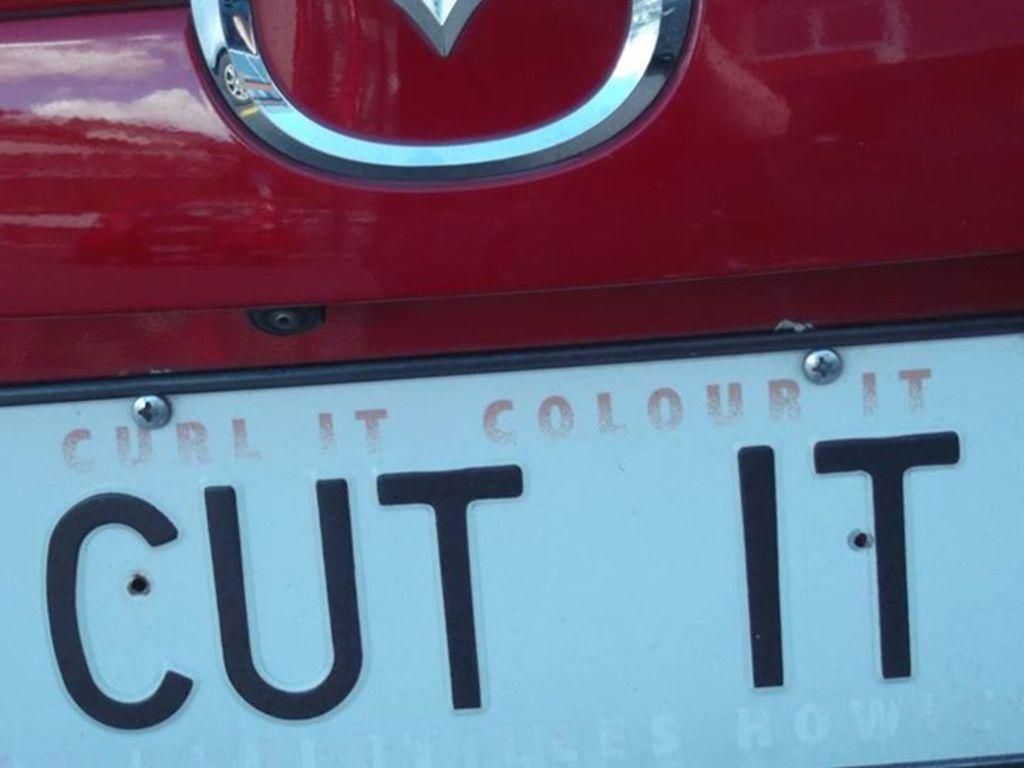<image>
Summarize the visual content of the image. A licence plate on a red car that says Cut It 